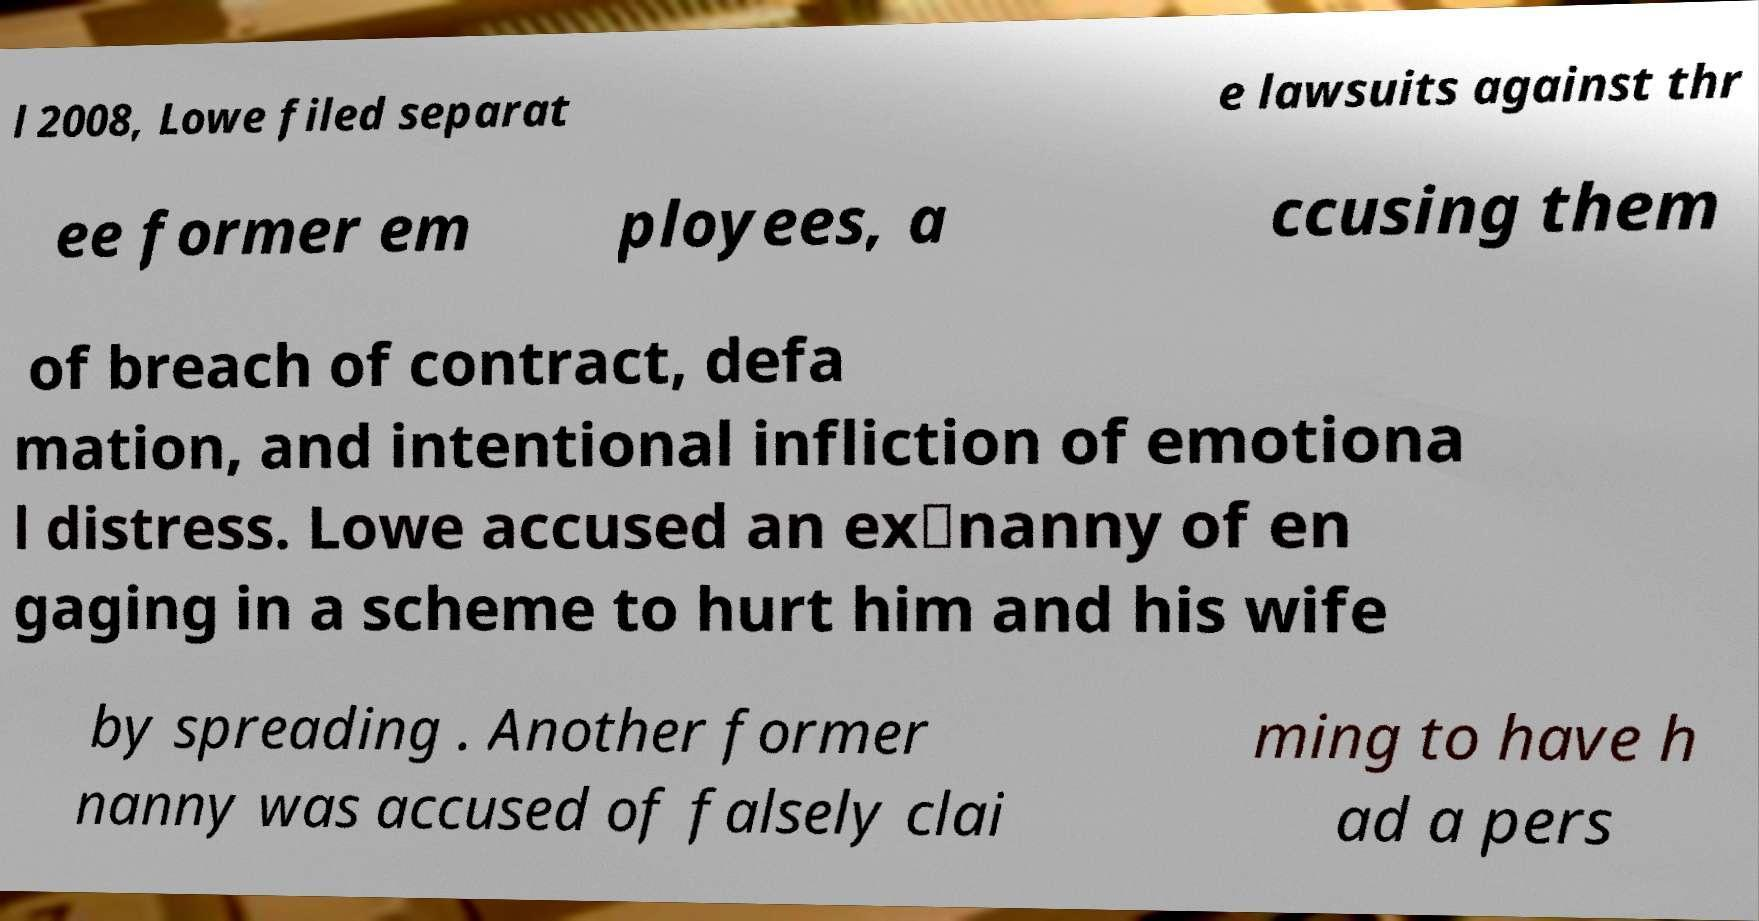Can you read and provide the text displayed in the image?This photo seems to have some interesting text. Can you extract and type it out for me? l 2008, Lowe filed separat e lawsuits against thr ee former em ployees, a ccusing them of breach of contract, defa mation, and intentional infliction of emotiona l distress. Lowe accused an ex‑nanny of en gaging in a scheme to hurt him and his wife by spreading . Another former nanny was accused of falsely clai ming to have h ad a pers 